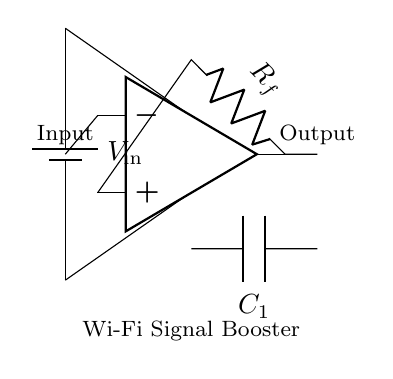What is the function of the op-amp in this circuit? The op-amp amplifies the input Wi-Fi signal, increasing its strength for better coverage.
Answer: Amplification What component is used to stabilize the circuit? The capacitor labeled C1 helps stabilize the circuit by filtering out noise and ensuring a smooth operation of the amplifier.
Answer: Capacitor What is the role of the feedback resistor in the circuit? The feedback resistor Rf is used to set the gain of the op-amp, controlling how much the input signal is amplified.
Answer: Gain control What type of antennas are in the circuit? The circuit includes two antennas, one for input and one for output, which are essential for receiving and transmitting the Wi-Fi signals.
Answer: Antenna How many antennas are present in the circuit? There are two antennas shown in the circuit, one connected to the input and the other connected to the output of the amplifier.
Answer: Two What is the power supply voltage indicated in the circuit? The circuit diagram indicates a voltage source labeled V_in, but the specific voltage value is not given; it's essential for powering the circuit's components.
Answer: V_in What is the primary objective of this circuit? The primary objective of this circuit is to boost the Wi-Fi signal, enhancing the coverage of the home network.
Answer: Wi-Fi signal booster 